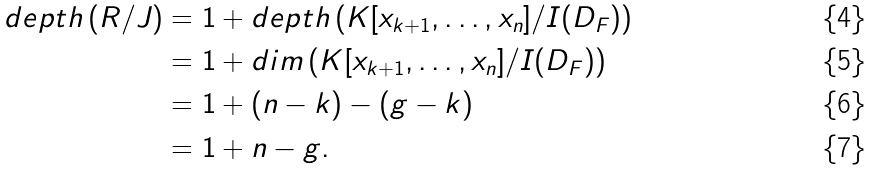Convert formula to latex. <formula><loc_0><loc_0><loc_500><loc_500>d e p t h \, ( R / J ) & = 1 + d e p t h \, ( K [ x _ { k + 1 } , \dots , x _ { n } ] / I ( D _ { F } ) ) \\ & = 1 + d i m \, ( K [ x _ { k + 1 } , \dots , x _ { n } ] / I ( D _ { F } ) ) \\ & = 1 + ( n - k ) - ( g - k ) \\ & = 1 + n - g .</formula> 